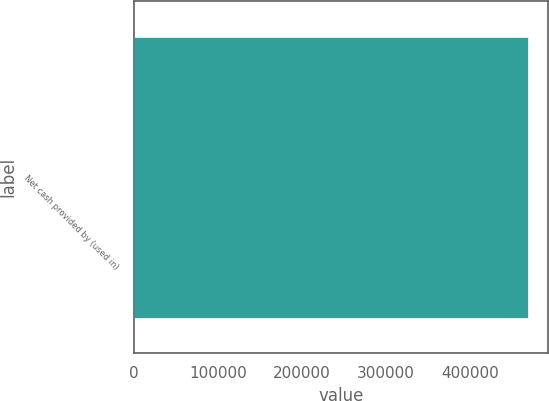Convert chart to OTSL. <chart><loc_0><loc_0><loc_500><loc_500><bar_chart><fcel>Net cash provided by (used in)<nl><fcel>469438<nl></chart> 